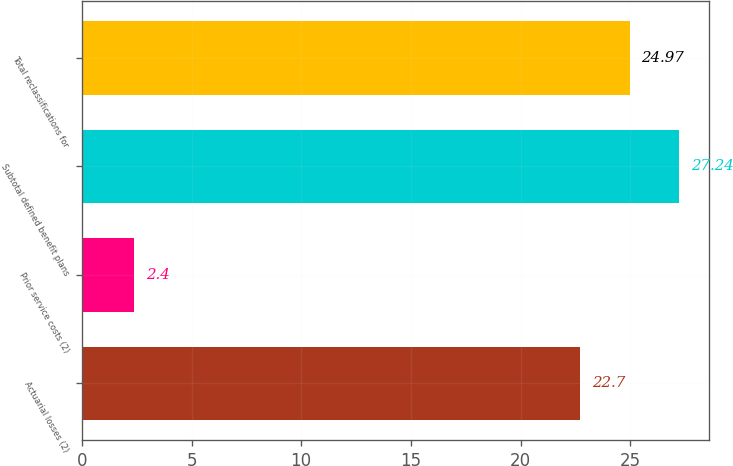Convert chart. <chart><loc_0><loc_0><loc_500><loc_500><bar_chart><fcel>Actuarial losses (2)<fcel>Prior service costs (2)<fcel>Subtotal defined benefit plans<fcel>Total reclassifications for<nl><fcel>22.7<fcel>2.4<fcel>27.24<fcel>24.97<nl></chart> 